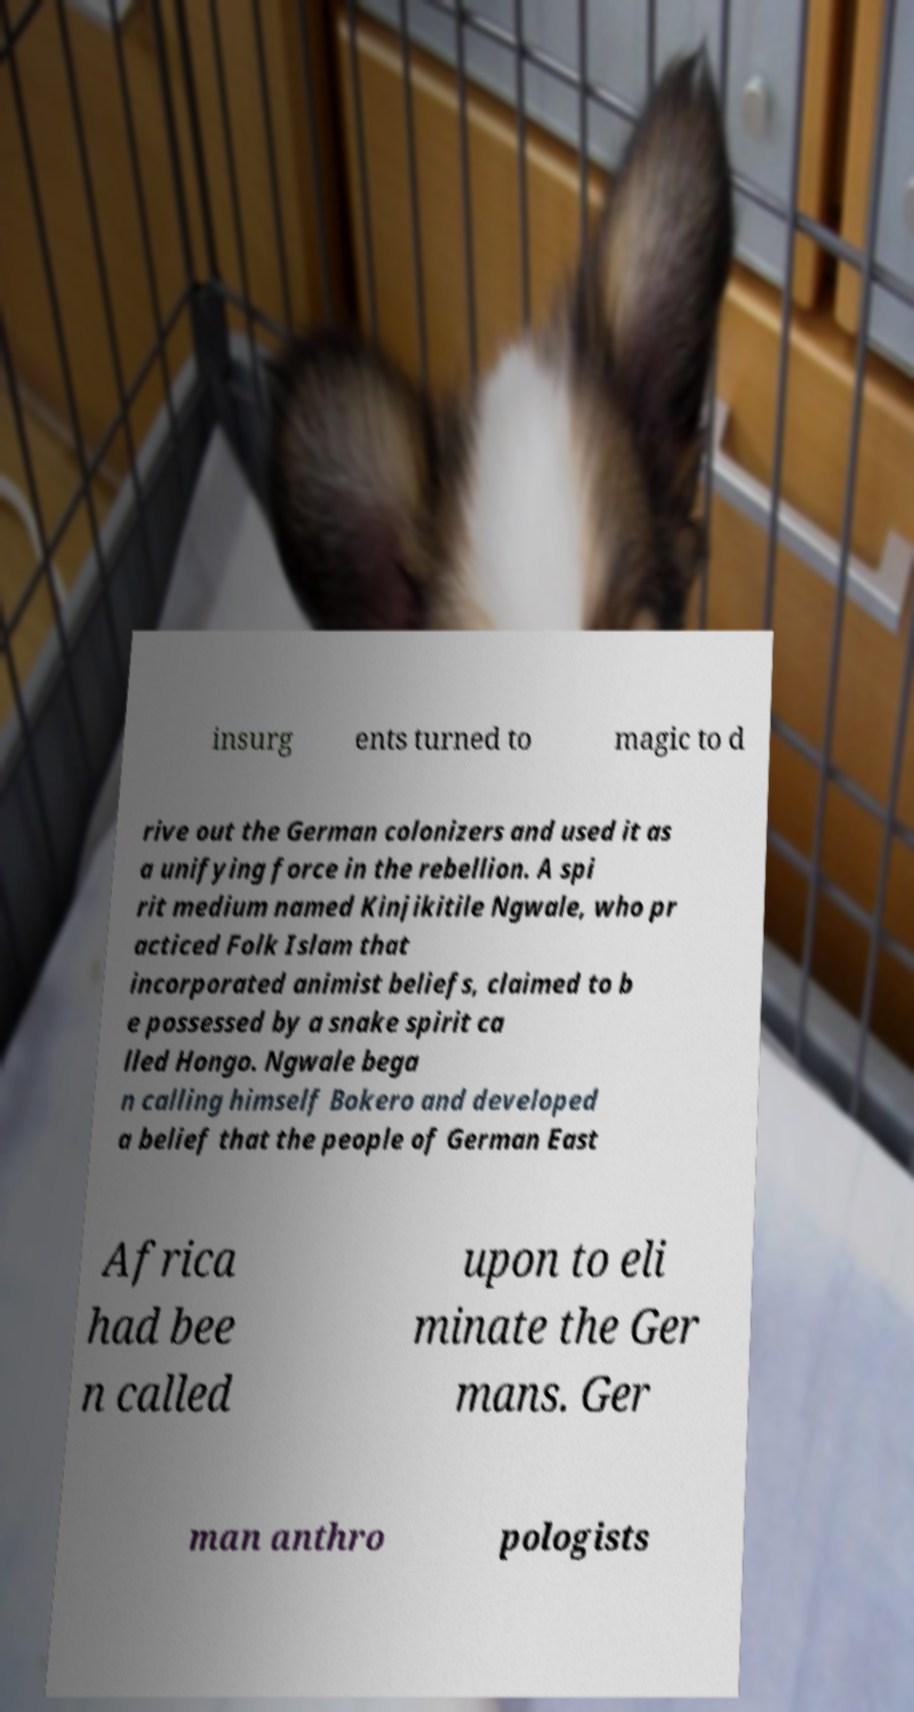For documentation purposes, I need the text within this image transcribed. Could you provide that? insurg ents turned to magic to d rive out the German colonizers and used it as a unifying force in the rebellion. A spi rit medium named Kinjikitile Ngwale, who pr acticed Folk Islam that incorporated animist beliefs, claimed to b e possessed by a snake spirit ca lled Hongo. Ngwale bega n calling himself Bokero and developed a belief that the people of German East Africa had bee n called upon to eli minate the Ger mans. Ger man anthro pologists 